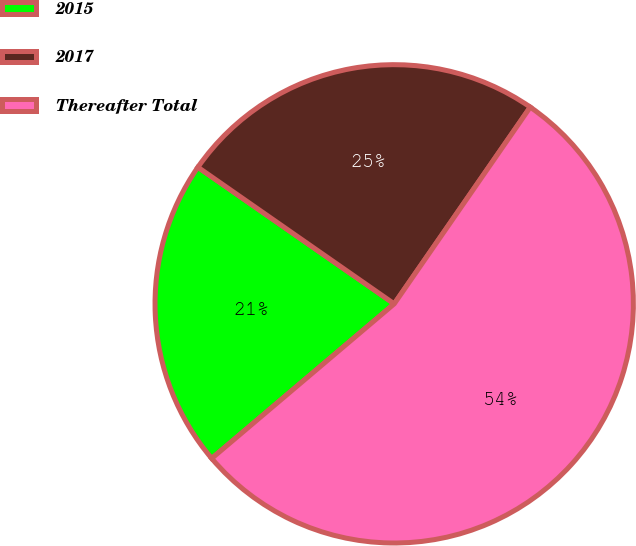Convert chart. <chart><loc_0><loc_0><loc_500><loc_500><pie_chart><fcel>2015<fcel>2017<fcel>Thereafter Total<nl><fcel>20.86%<fcel>24.95%<fcel>54.18%<nl></chart> 